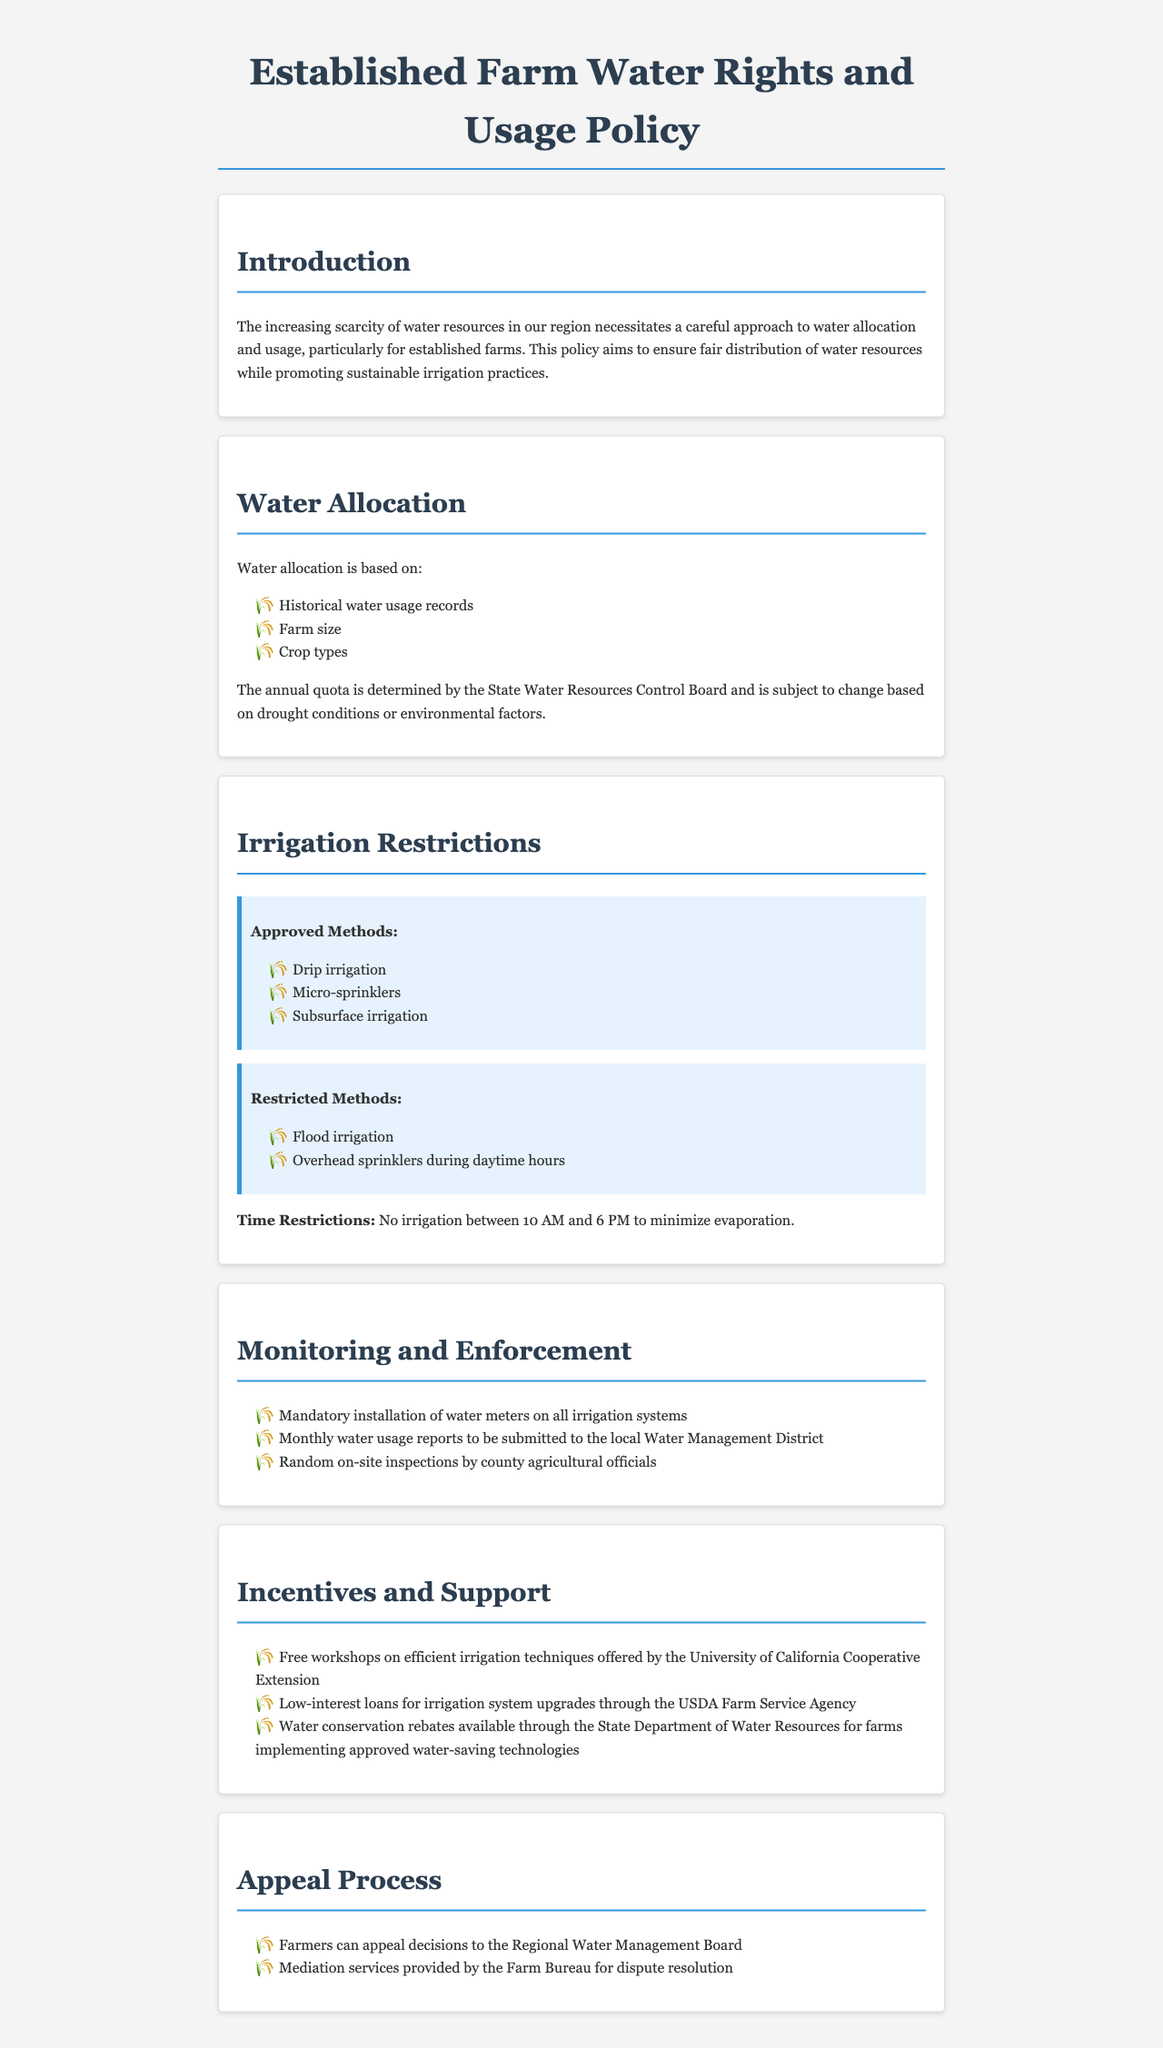What is the purpose of the policy? The document states that the purpose of the policy is to ensure fair distribution of water resources while promoting sustainable irrigation practices.
Answer: fair distribution of water resources and sustainable irrigation practices What factors determine water allocation? Water allocation is based on historical water usage records, farm size, and crop types.
Answer: historical water usage records, farm size, crop types Which irrigation methods are restricted? The document lists flood irrigation and overhead sprinklers during daytime hours as restricted methods.
Answer: flood irrigation, overhead sprinklers during daytime hours What are the time restrictions for irrigation? The document states that there are no irrigation activities allowed between 10 AM and 6 PM to minimize evaporation.
Answer: between 10 AM and 6 PM What type of monitoring is required? Farmers are required to install water meters on all irrigation systems and submit monthly water usage reports.
Answer: installation of water meters and monthly water usage reports What support is available for farmers? The document provides information about free workshops, low-interest loans, and water conservation rebates as support for farmers.
Answer: free workshops, low-interest loans, water conservation rebates How can farmers appeal decisions made under the policy? Farmers can appeal decisions to the Regional Water Management Board.
Answer: Regional Water Management Board Who offers workshops on efficient irrigation techniques? The University of California Cooperative Extension offers workshops on efficient irrigation techniques.
Answer: University of California Cooperative Extension 